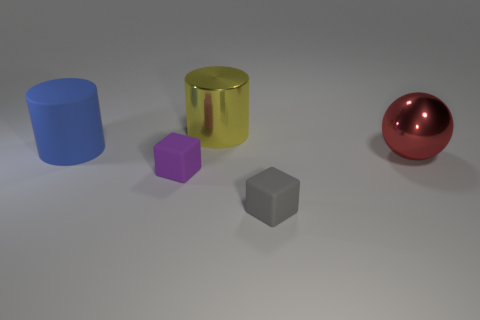What color is the thing that is behind the purple thing and in front of the blue object?
Provide a succinct answer. Red. There is a yellow cylinder; is it the same size as the rubber block that is to the left of the small gray rubber object?
Your answer should be very brief. No. What is the shape of the metal thing left of the small gray matte block?
Provide a short and direct response. Cylinder. Is there any other thing that is made of the same material as the purple object?
Your answer should be compact. Yes. Are there more yellow things that are left of the big blue rubber thing than cylinders?
Offer a terse response. No. How many gray matte cubes are to the right of the small block in front of the tiny block left of the yellow cylinder?
Offer a terse response. 0. There is a shiny object behind the red sphere; does it have the same size as the shiny object in front of the large rubber thing?
Provide a succinct answer. Yes. What material is the block that is in front of the small rubber thing that is behind the small gray matte thing?
Your response must be concise. Rubber. How many objects are either rubber things behind the big red metallic thing or large blue things?
Keep it short and to the point. 1. Are there an equal number of small rubber objects on the left side of the big matte cylinder and big matte cylinders on the left side of the yellow metallic thing?
Provide a succinct answer. No. 